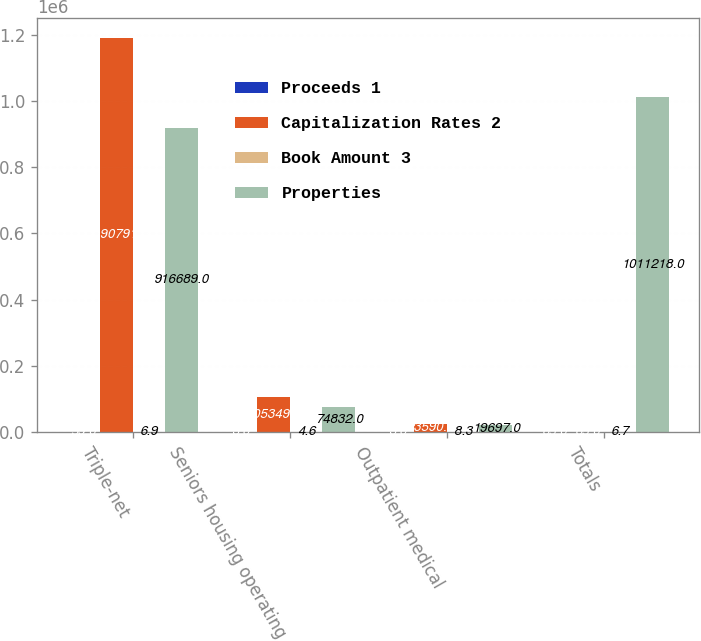Convert chart to OTSL. <chart><loc_0><loc_0><loc_500><loc_500><stacked_bar_chart><ecel><fcel>Triple-net<fcel>Seniors housing operating<fcel>Outpatient medical<fcel>Totals<nl><fcel>Proceeds 1<fcel>59<fcel>3<fcel>3<fcel>65<nl><fcel>Capitalization Rates 2<fcel>1.19079e+06<fcel>105349<fcel>23590<fcel>65<nl><fcel>Book Amount 3<fcel>6.9<fcel>4.6<fcel>8.3<fcel>6.7<nl><fcel>Properties<fcel>916689<fcel>74832<fcel>19697<fcel>1.01122e+06<nl></chart> 